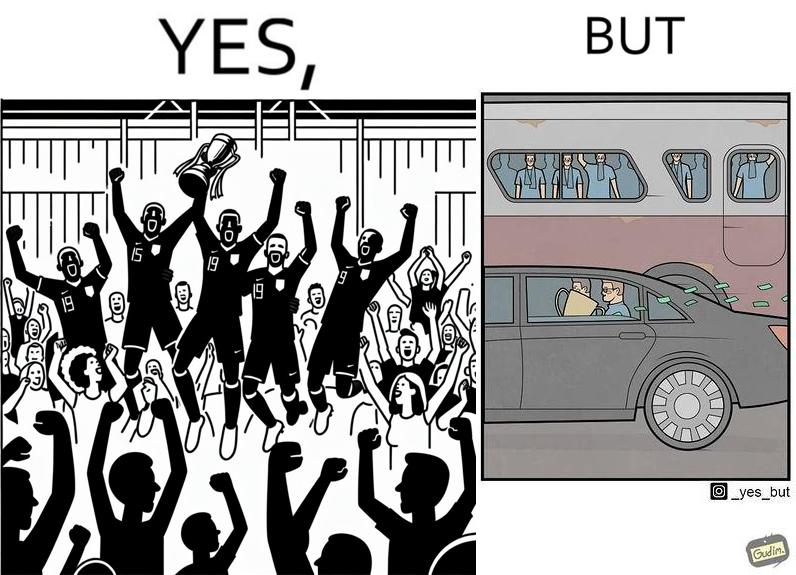Why is this image considered satirical? The image is ironical, as a team and its are all celebrating on the ground after winning the match, but after the match, the fans are standing in the bus uncomfortably, while the players are travelling inside a carring the cup as well as the prize money, which the fans did not get a dime of. 